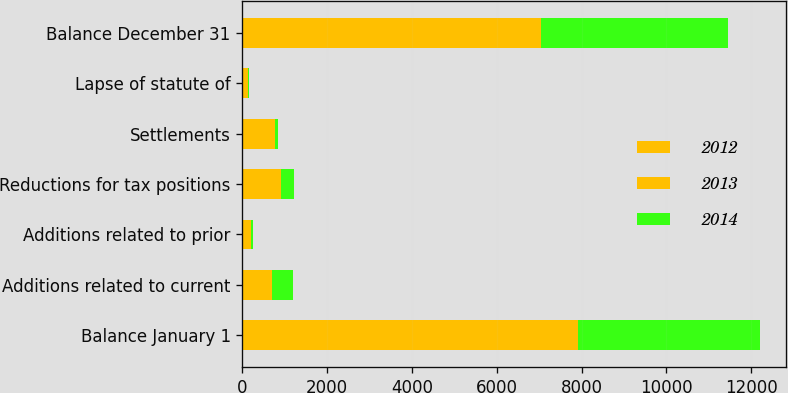<chart> <loc_0><loc_0><loc_500><loc_500><stacked_bar_chart><ecel><fcel>Balance January 1<fcel>Additions related to current<fcel>Additions related to prior<fcel>Reductions for tax positions<fcel>Settlements<fcel>Lapse of statute of<fcel>Balance December 31<nl><fcel>2012<fcel>3503<fcel>389<fcel>23<fcel>156<fcel>161<fcel>64<fcel>3534<nl><fcel>2013<fcel>4425<fcel>320<fcel>177<fcel>747<fcel>603<fcel>69<fcel>3503<nl><fcel>2014<fcel>4277<fcel>496<fcel>58<fcel>320<fcel>67<fcel>19<fcel>4425<nl></chart> 